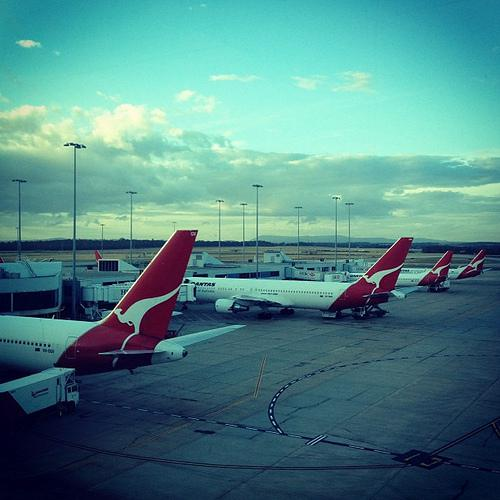Question: when will the planes take off?
Choices:
A. When all passengers are on.
B. When all luggage is onboard.
C. When fueling is done.
D. When other planes take off.
Answer with the letter. Answer: A Question: how many planes are shown?
Choices:
A. 3.
B. 2.
C. 4.
D. 1.
Answer with the letter. Answer: C Question: why is there are kangaroo on the tail of the plane?
Choices:
A. Emblem of company's name.
B. Kangaroo Airlines.
C. It is an  Australia airline.
D. It is a Qantas aircraft.
Answer with the letter. Answer: B Question: where are the clouds?
Choices:
A. Over the valley.
B. Over the mountain top.
C. Over the ocean.
D. In the sky.
Answer with the letter. Answer: D Question: why is it bright outside?
Choices:
A. Glare due to haze.
B. It is noon.
C. The sun is shining.
D. Reflection from water.
Answer with the letter. Answer: C 